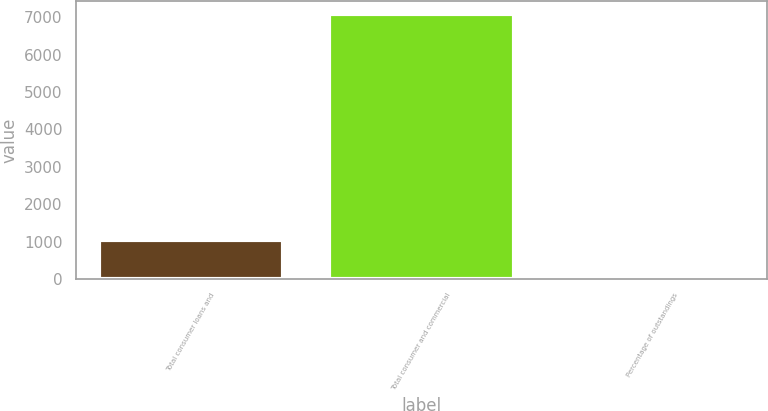<chart> <loc_0><loc_0><loc_500><loc_500><bar_chart><fcel>Total consumer loans and<fcel>Total consumer and commercial<fcel>Percentage of outstandings<nl><fcel>1051<fcel>7085<fcel>0.77<nl></chart> 